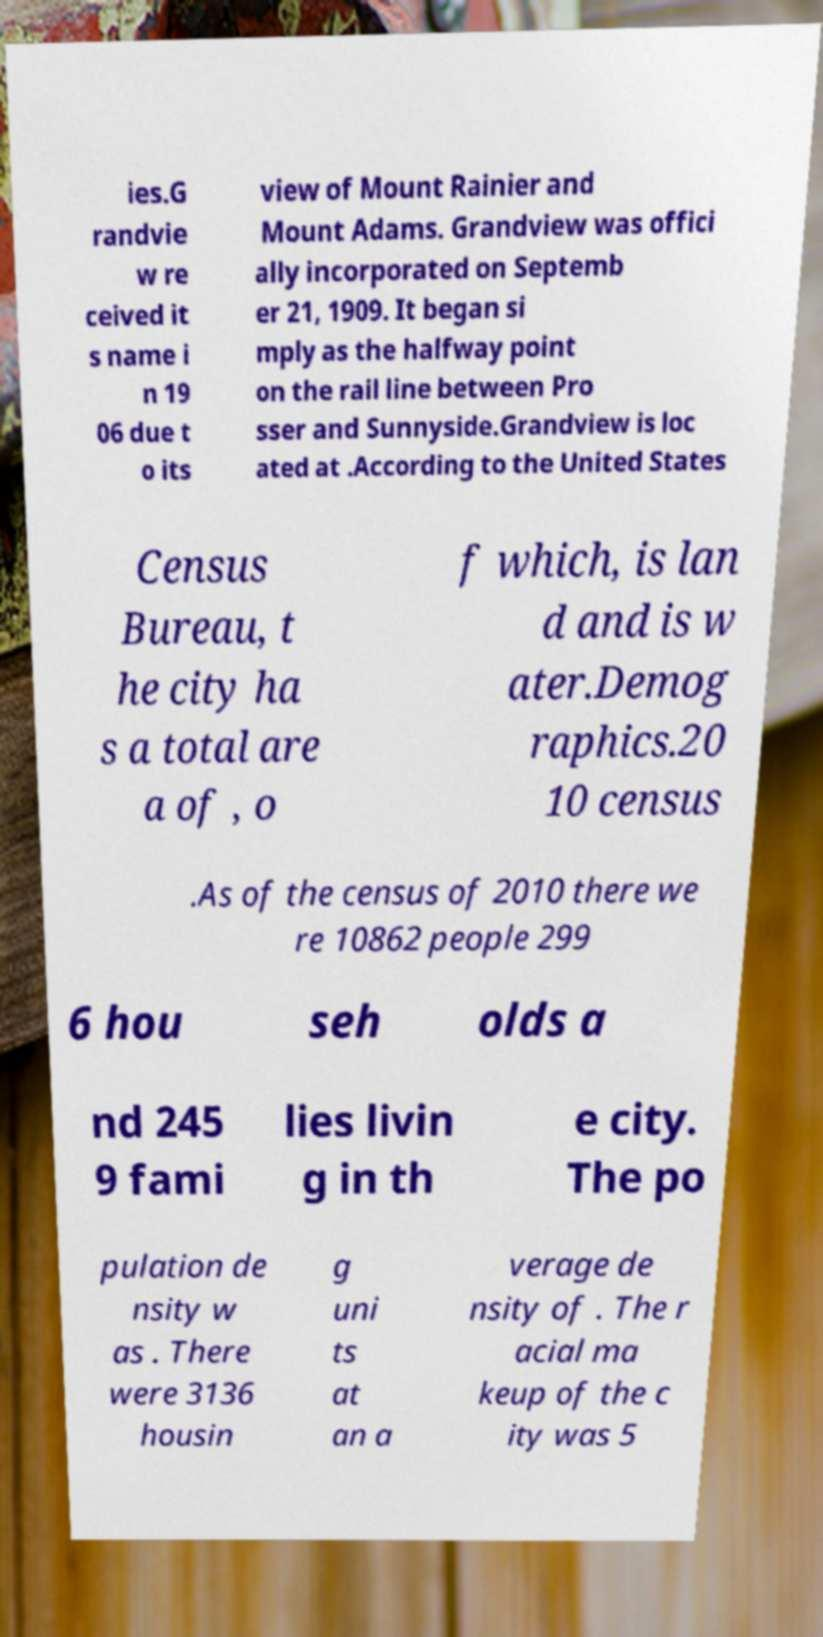Can you read and provide the text displayed in the image?This photo seems to have some interesting text. Can you extract and type it out for me? ies.G randvie w re ceived it s name i n 19 06 due t o its view of Mount Rainier and Mount Adams. Grandview was offici ally incorporated on Septemb er 21, 1909. It began si mply as the halfway point on the rail line between Pro sser and Sunnyside.Grandview is loc ated at .According to the United States Census Bureau, t he city ha s a total are a of , o f which, is lan d and is w ater.Demog raphics.20 10 census .As of the census of 2010 there we re 10862 people 299 6 hou seh olds a nd 245 9 fami lies livin g in th e city. The po pulation de nsity w as . There were 3136 housin g uni ts at an a verage de nsity of . The r acial ma keup of the c ity was 5 